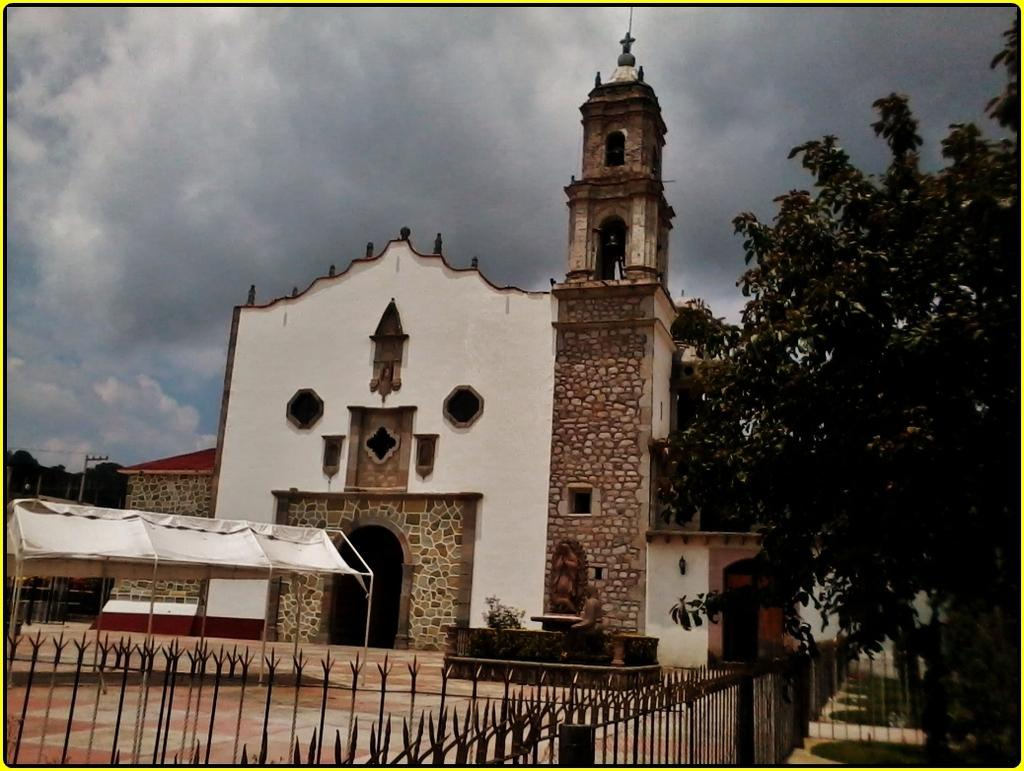What type of structure is visible in the image? There is a building in the image. What is located beside the building? There is a fence beside the building. What type of vegetation can be seen in the image? There is a tree in the right corner of the image. How would you describe the weather based on the image? The sky is cloudy in the image. What type of record is being played in the image? There is no record or music player visible in the image. 